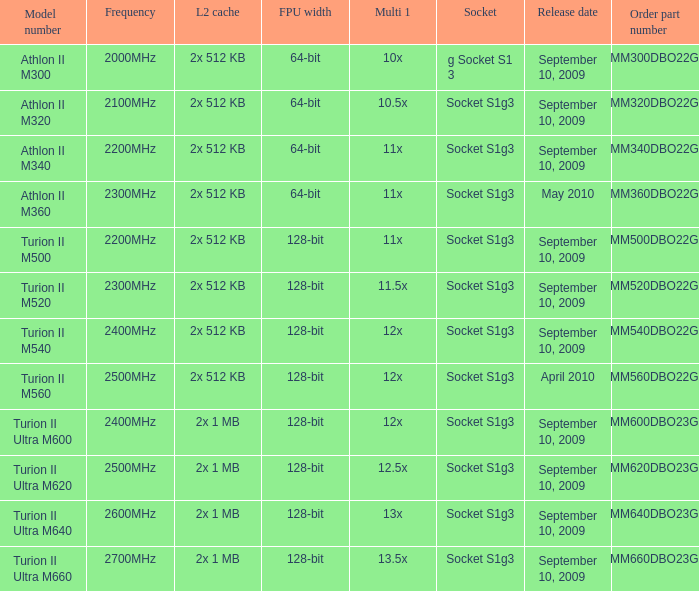What is the L2 cache with a release date on September 10, 2009, a 128-bit FPU width, and a 12x multi 1? 2x 512 KB, 2x 1 MB. 